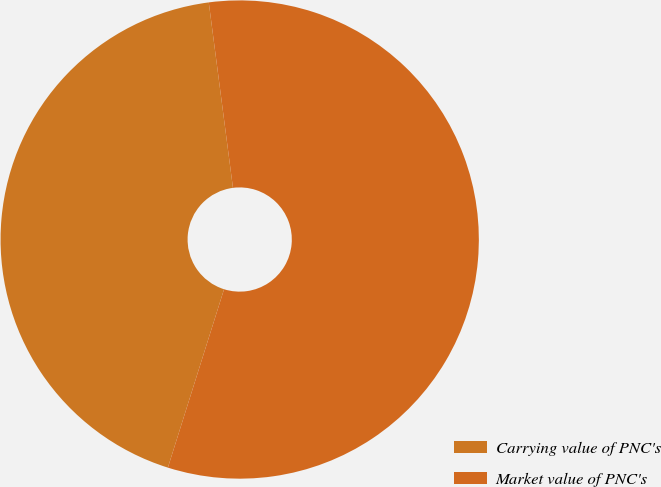Convert chart. <chart><loc_0><loc_0><loc_500><loc_500><pie_chart><fcel>Carrying value of PNC's<fcel>Market value of PNC's<nl><fcel>43.08%<fcel>56.92%<nl></chart> 